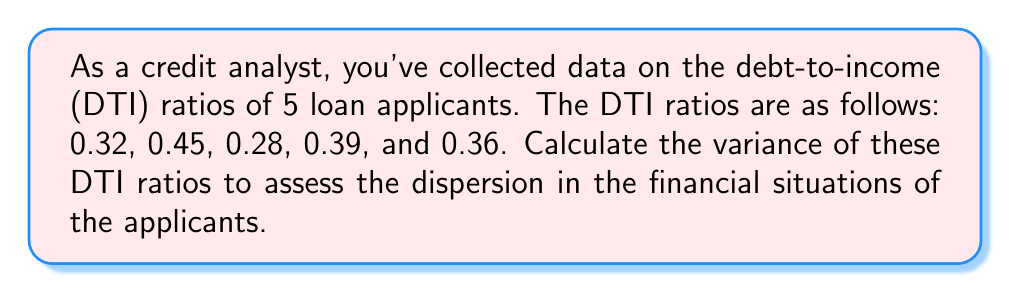Can you answer this question? To calculate the variance of the debt-to-income ratios, we'll follow these steps:

1. Calculate the mean (average) of the DTI ratios:
   $$\mu = \frac{0.32 + 0.45 + 0.28 + 0.39 + 0.36}{5} = 0.36$$

2. Calculate the squared differences from the mean for each DTI ratio:
   $$(0.32 - 0.36)^2 = (-0.04)^2 = 0.0016$$
   $$(0.45 - 0.36)^2 = (0.09)^2 = 0.0081$$
   $$(0.28 - 0.36)^2 = (-0.08)^2 = 0.0064$$
   $$(0.39 - 0.36)^2 = (0.03)^2 = 0.0009$$
   $$(0.36 - 0.36)^2 = (0)^2 = 0$$

3. Sum the squared differences:
   $$0.0016 + 0.0081 + 0.0064 + 0.0009 + 0 = 0.017$$

4. Divide the sum by the number of observations (n=5) to get the variance:
   $$\text{Variance} = \frac{0.017}{5} = 0.0034$$

The formula for variance is:
$$\sigma^2 = \frac{\sum_{i=1}^n (x_i - \mu)^2}{n}$$

where $\sigma^2$ is the variance, $x_i$ are the individual values, $\mu$ is the mean, and $n$ is the number of observations.
Answer: 0.0034 